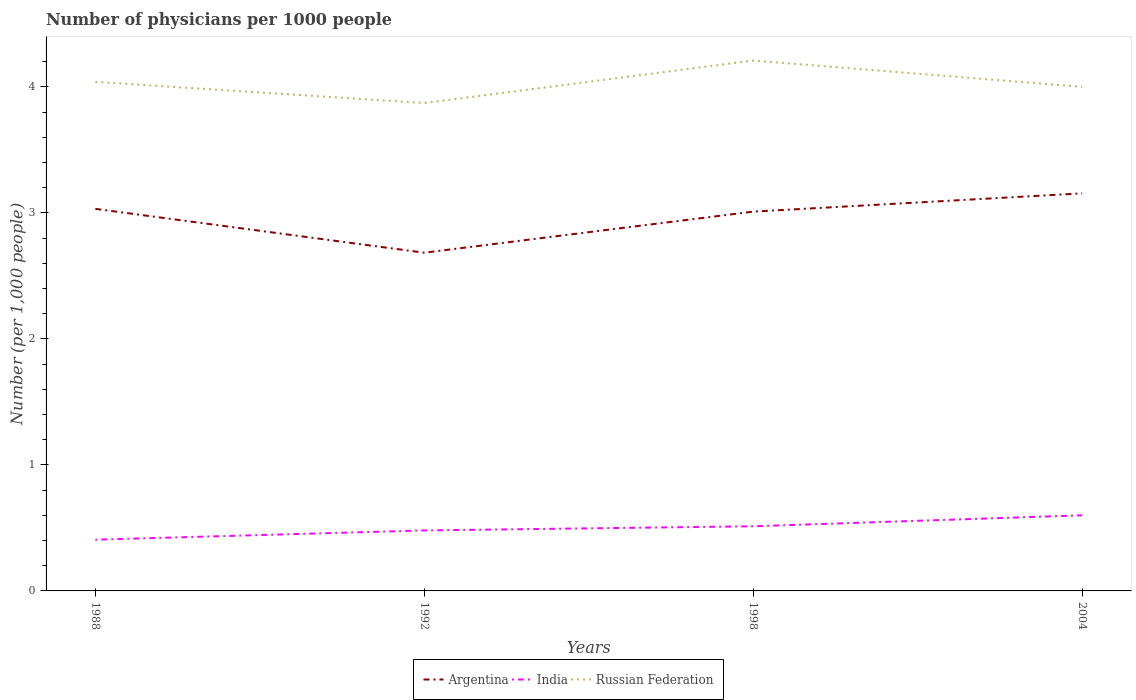Does the line corresponding to Argentina intersect with the line corresponding to Russian Federation?
Provide a short and direct response. No. Is the number of lines equal to the number of legend labels?
Keep it short and to the point. Yes. Across all years, what is the maximum number of physicians in India?
Your response must be concise. 0.41. What is the total number of physicians in India in the graph?
Your answer should be compact. -0.03. What is the difference between the highest and the second highest number of physicians in India?
Keep it short and to the point. 0.19. What is the difference between the highest and the lowest number of physicians in Argentina?
Your answer should be very brief. 3. Is the number of physicians in India strictly greater than the number of physicians in Russian Federation over the years?
Provide a succinct answer. Yes. How many lines are there?
Give a very brief answer. 3. How many years are there in the graph?
Keep it short and to the point. 4. Does the graph contain grids?
Ensure brevity in your answer.  No. Where does the legend appear in the graph?
Ensure brevity in your answer.  Bottom center. What is the title of the graph?
Keep it short and to the point. Number of physicians per 1000 people. What is the label or title of the Y-axis?
Your answer should be compact. Number (per 1,0 people). What is the Number (per 1,000 people) of Argentina in 1988?
Give a very brief answer. 3.03. What is the Number (per 1,000 people) of India in 1988?
Keep it short and to the point. 0.41. What is the Number (per 1,000 people) of Russian Federation in 1988?
Keep it short and to the point. 4.04. What is the Number (per 1,000 people) in Argentina in 1992?
Offer a very short reply. 2.68. What is the Number (per 1,000 people) in India in 1992?
Provide a short and direct response. 0.48. What is the Number (per 1,000 people) in Russian Federation in 1992?
Provide a short and direct response. 3.87. What is the Number (per 1,000 people) of Argentina in 1998?
Your answer should be compact. 3.01. What is the Number (per 1,000 people) in India in 1998?
Your answer should be very brief. 0.51. What is the Number (per 1,000 people) in Russian Federation in 1998?
Your answer should be very brief. 4.21. What is the Number (per 1,000 people) of Argentina in 2004?
Keep it short and to the point. 3.15. What is the Number (per 1,000 people) in India in 2004?
Your response must be concise. 0.6. Across all years, what is the maximum Number (per 1,000 people) in Argentina?
Give a very brief answer. 3.15. Across all years, what is the maximum Number (per 1,000 people) of Russian Federation?
Your response must be concise. 4.21. Across all years, what is the minimum Number (per 1,000 people) of Argentina?
Your answer should be compact. 2.68. Across all years, what is the minimum Number (per 1,000 people) of India?
Give a very brief answer. 0.41. Across all years, what is the minimum Number (per 1,000 people) in Russian Federation?
Your answer should be very brief. 3.87. What is the total Number (per 1,000 people) in Argentina in the graph?
Ensure brevity in your answer.  11.88. What is the total Number (per 1,000 people) of India in the graph?
Offer a terse response. 2. What is the total Number (per 1,000 people) of Russian Federation in the graph?
Make the answer very short. 16.12. What is the difference between the Number (per 1,000 people) in Argentina in 1988 and that in 1992?
Your answer should be compact. 0.35. What is the difference between the Number (per 1,000 people) of India in 1988 and that in 1992?
Your response must be concise. -0.07. What is the difference between the Number (per 1,000 people) of Russian Federation in 1988 and that in 1992?
Ensure brevity in your answer.  0.17. What is the difference between the Number (per 1,000 people) of Argentina in 1988 and that in 1998?
Your answer should be compact. 0.02. What is the difference between the Number (per 1,000 people) of India in 1988 and that in 1998?
Ensure brevity in your answer.  -0.11. What is the difference between the Number (per 1,000 people) in Russian Federation in 1988 and that in 1998?
Keep it short and to the point. -0.17. What is the difference between the Number (per 1,000 people) of Argentina in 1988 and that in 2004?
Your answer should be very brief. -0.12. What is the difference between the Number (per 1,000 people) in India in 1988 and that in 2004?
Give a very brief answer. -0.19. What is the difference between the Number (per 1,000 people) of Russian Federation in 1988 and that in 2004?
Your answer should be very brief. 0.04. What is the difference between the Number (per 1,000 people) in Argentina in 1992 and that in 1998?
Provide a succinct answer. -0.33. What is the difference between the Number (per 1,000 people) of India in 1992 and that in 1998?
Offer a very short reply. -0.03. What is the difference between the Number (per 1,000 people) in Russian Federation in 1992 and that in 1998?
Provide a short and direct response. -0.34. What is the difference between the Number (per 1,000 people) of Argentina in 1992 and that in 2004?
Your answer should be compact. -0.47. What is the difference between the Number (per 1,000 people) of India in 1992 and that in 2004?
Your response must be concise. -0.12. What is the difference between the Number (per 1,000 people) in Russian Federation in 1992 and that in 2004?
Offer a very short reply. -0.13. What is the difference between the Number (per 1,000 people) of Argentina in 1998 and that in 2004?
Provide a succinct answer. -0.14. What is the difference between the Number (per 1,000 people) of India in 1998 and that in 2004?
Offer a terse response. -0.09. What is the difference between the Number (per 1,000 people) in Russian Federation in 1998 and that in 2004?
Provide a short and direct response. 0.21. What is the difference between the Number (per 1,000 people) in Argentina in 1988 and the Number (per 1,000 people) in India in 1992?
Keep it short and to the point. 2.55. What is the difference between the Number (per 1,000 people) in Argentina in 1988 and the Number (per 1,000 people) in Russian Federation in 1992?
Ensure brevity in your answer.  -0.84. What is the difference between the Number (per 1,000 people) of India in 1988 and the Number (per 1,000 people) of Russian Federation in 1992?
Ensure brevity in your answer.  -3.47. What is the difference between the Number (per 1,000 people) in Argentina in 1988 and the Number (per 1,000 people) in India in 1998?
Provide a short and direct response. 2.52. What is the difference between the Number (per 1,000 people) in Argentina in 1988 and the Number (per 1,000 people) in Russian Federation in 1998?
Your answer should be very brief. -1.18. What is the difference between the Number (per 1,000 people) of India in 1988 and the Number (per 1,000 people) of Russian Federation in 1998?
Keep it short and to the point. -3.8. What is the difference between the Number (per 1,000 people) in Argentina in 1988 and the Number (per 1,000 people) in India in 2004?
Your answer should be compact. 2.43. What is the difference between the Number (per 1,000 people) of Argentina in 1988 and the Number (per 1,000 people) of Russian Federation in 2004?
Your answer should be very brief. -0.97. What is the difference between the Number (per 1,000 people) of India in 1988 and the Number (per 1,000 people) of Russian Federation in 2004?
Provide a succinct answer. -3.59. What is the difference between the Number (per 1,000 people) of Argentina in 1992 and the Number (per 1,000 people) of India in 1998?
Provide a short and direct response. 2.17. What is the difference between the Number (per 1,000 people) in Argentina in 1992 and the Number (per 1,000 people) in Russian Federation in 1998?
Keep it short and to the point. -1.52. What is the difference between the Number (per 1,000 people) in India in 1992 and the Number (per 1,000 people) in Russian Federation in 1998?
Provide a short and direct response. -3.73. What is the difference between the Number (per 1,000 people) in Argentina in 1992 and the Number (per 1,000 people) in India in 2004?
Offer a terse response. 2.08. What is the difference between the Number (per 1,000 people) in Argentina in 1992 and the Number (per 1,000 people) in Russian Federation in 2004?
Offer a very short reply. -1.32. What is the difference between the Number (per 1,000 people) of India in 1992 and the Number (per 1,000 people) of Russian Federation in 2004?
Provide a succinct answer. -3.52. What is the difference between the Number (per 1,000 people) in Argentina in 1998 and the Number (per 1,000 people) in India in 2004?
Keep it short and to the point. 2.41. What is the difference between the Number (per 1,000 people) of Argentina in 1998 and the Number (per 1,000 people) of Russian Federation in 2004?
Provide a short and direct response. -0.99. What is the difference between the Number (per 1,000 people) in India in 1998 and the Number (per 1,000 people) in Russian Federation in 2004?
Give a very brief answer. -3.49. What is the average Number (per 1,000 people) of Argentina per year?
Offer a very short reply. 2.97. What is the average Number (per 1,000 people) of India per year?
Offer a very short reply. 0.5. What is the average Number (per 1,000 people) of Russian Federation per year?
Provide a succinct answer. 4.03. In the year 1988, what is the difference between the Number (per 1,000 people) of Argentina and Number (per 1,000 people) of India?
Ensure brevity in your answer.  2.63. In the year 1988, what is the difference between the Number (per 1,000 people) of Argentina and Number (per 1,000 people) of Russian Federation?
Ensure brevity in your answer.  -1.01. In the year 1988, what is the difference between the Number (per 1,000 people) in India and Number (per 1,000 people) in Russian Federation?
Your answer should be compact. -3.63. In the year 1992, what is the difference between the Number (per 1,000 people) of Argentina and Number (per 1,000 people) of India?
Keep it short and to the point. 2.2. In the year 1992, what is the difference between the Number (per 1,000 people) of Argentina and Number (per 1,000 people) of Russian Federation?
Offer a very short reply. -1.19. In the year 1992, what is the difference between the Number (per 1,000 people) of India and Number (per 1,000 people) of Russian Federation?
Provide a short and direct response. -3.39. In the year 1998, what is the difference between the Number (per 1,000 people) in Argentina and Number (per 1,000 people) in India?
Keep it short and to the point. 2.5. In the year 1998, what is the difference between the Number (per 1,000 people) of Argentina and Number (per 1,000 people) of Russian Federation?
Make the answer very short. -1.2. In the year 1998, what is the difference between the Number (per 1,000 people) of India and Number (per 1,000 people) of Russian Federation?
Offer a very short reply. -3.7. In the year 2004, what is the difference between the Number (per 1,000 people) of Argentina and Number (per 1,000 people) of India?
Provide a succinct answer. 2.56. In the year 2004, what is the difference between the Number (per 1,000 people) in Argentina and Number (per 1,000 people) in Russian Federation?
Keep it short and to the point. -0.84. In the year 2004, what is the difference between the Number (per 1,000 people) of India and Number (per 1,000 people) of Russian Federation?
Give a very brief answer. -3.4. What is the ratio of the Number (per 1,000 people) in Argentina in 1988 to that in 1992?
Your answer should be very brief. 1.13. What is the ratio of the Number (per 1,000 people) in India in 1988 to that in 1992?
Keep it short and to the point. 0.85. What is the ratio of the Number (per 1,000 people) in Russian Federation in 1988 to that in 1992?
Make the answer very short. 1.04. What is the ratio of the Number (per 1,000 people) of Argentina in 1988 to that in 1998?
Make the answer very short. 1.01. What is the ratio of the Number (per 1,000 people) in India in 1988 to that in 1998?
Make the answer very short. 0.79. What is the ratio of the Number (per 1,000 people) of Russian Federation in 1988 to that in 1998?
Offer a terse response. 0.96. What is the ratio of the Number (per 1,000 people) in Argentina in 1988 to that in 2004?
Provide a succinct answer. 0.96. What is the ratio of the Number (per 1,000 people) in India in 1988 to that in 2004?
Provide a succinct answer. 0.68. What is the ratio of the Number (per 1,000 people) in Russian Federation in 1988 to that in 2004?
Provide a succinct answer. 1.01. What is the ratio of the Number (per 1,000 people) in Argentina in 1992 to that in 1998?
Provide a succinct answer. 0.89. What is the ratio of the Number (per 1,000 people) of India in 1992 to that in 1998?
Make the answer very short. 0.94. What is the ratio of the Number (per 1,000 people) in Russian Federation in 1992 to that in 1998?
Ensure brevity in your answer.  0.92. What is the ratio of the Number (per 1,000 people) in Argentina in 1992 to that in 2004?
Your answer should be compact. 0.85. What is the ratio of the Number (per 1,000 people) of Russian Federation in 1992 to that in 2004?
Provide a succinct answer. 0.97. What is the ratio of the Number (per 1,000 people) in Argentina in 1998 to that in 2004?
Offer a terse response. 0.95. What is the ratio of the Number (per 1,000 people) of India in 1998 to that in 2004?
Make the answer very short. 0.85. What is the ratio of the Number (per 1,000 people) of Russian Federation in 1998 to that in 2004?
Offer a terse response. 1.05. What is the difference between the highest and the second highest Number (per 1,000 people) in Argentina?
Provide a succinct answer. 0.12. What is the difference between the highest and the second highest Number (per 1,000 people) of India?
Keep it short and to the point. 0.09. What is the difference between the highest and the second highest Number (per 1,000 people) in Russian Federation?
Your answer should be very brief. 0.17. What is the difference between the highest and the lowest Number (per 1,000 people) of Argentina?
Your answer should be very brief. 0.47. What is the difference between the highest and the lowest Number (per 1,000 people) of India?
Your answer should be compact. 0.19. What is the difference between the highest and the lowest Number (per 1,000 people) of Russian Federation?
Offer a very short reply. 0.34. 